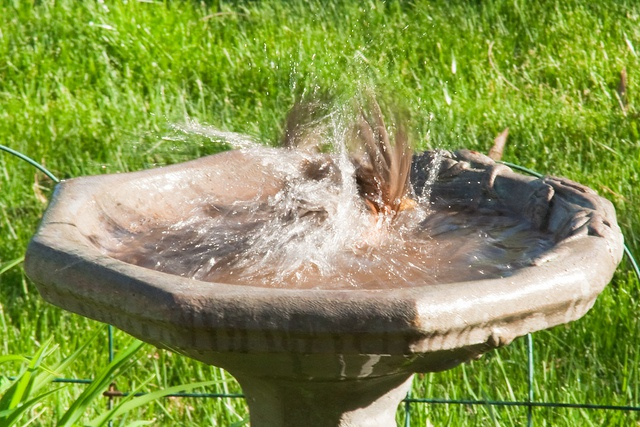Describe the objects in this image and their specific colors. I can see a bird in olive, tan, gray, and lightgray tones in this image. 